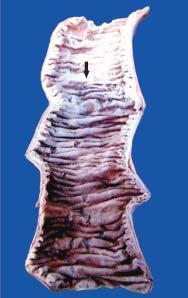s line of demarcation between gangrenous segment and the viable bowel not clear-cut?
Answer the question using a single word or phrase. No 